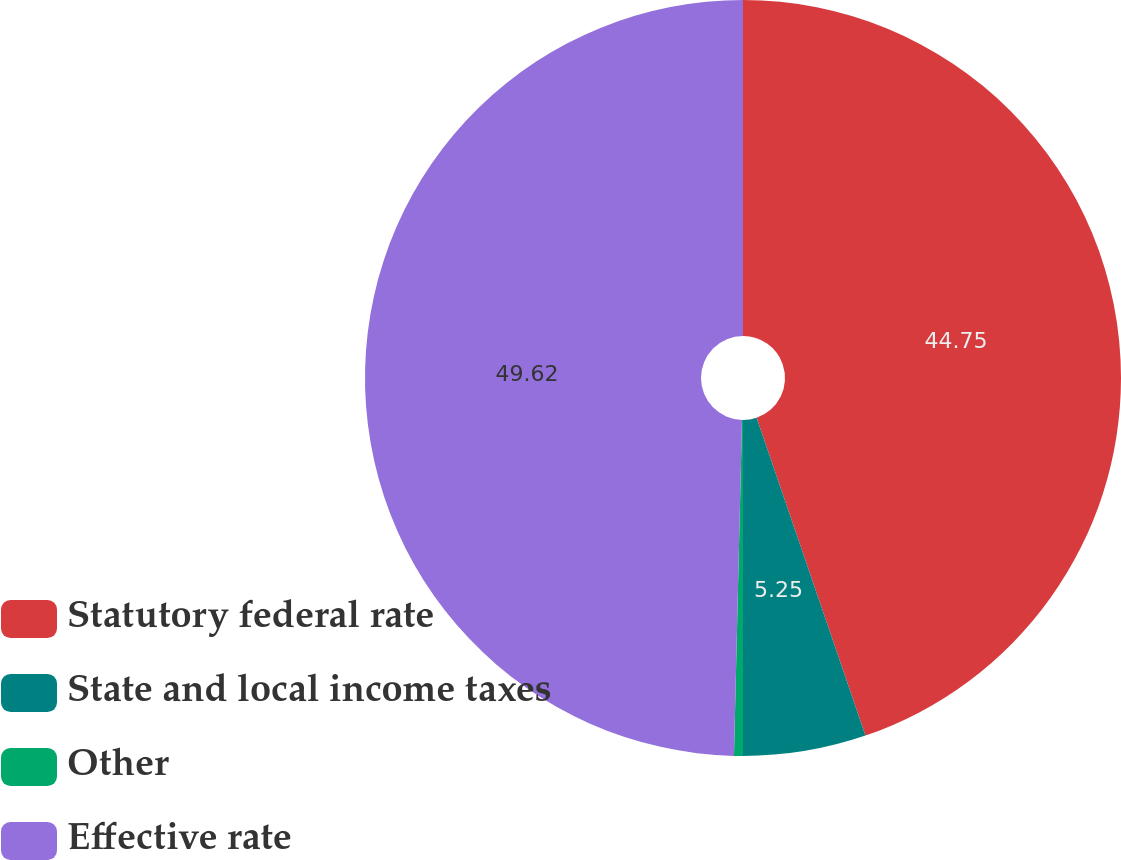Convert chart. <chart><loc_0><loc_0><loc_500><loc_500><pie_chart><fcel>Statutory federal rate<fcel>State and local income taxes<fcel>Other<fcel>Effective rate<nl><fcel>44.75%<fcel>5.25%<fcel>0.38%<fcel>49.62%<nl></chart> 